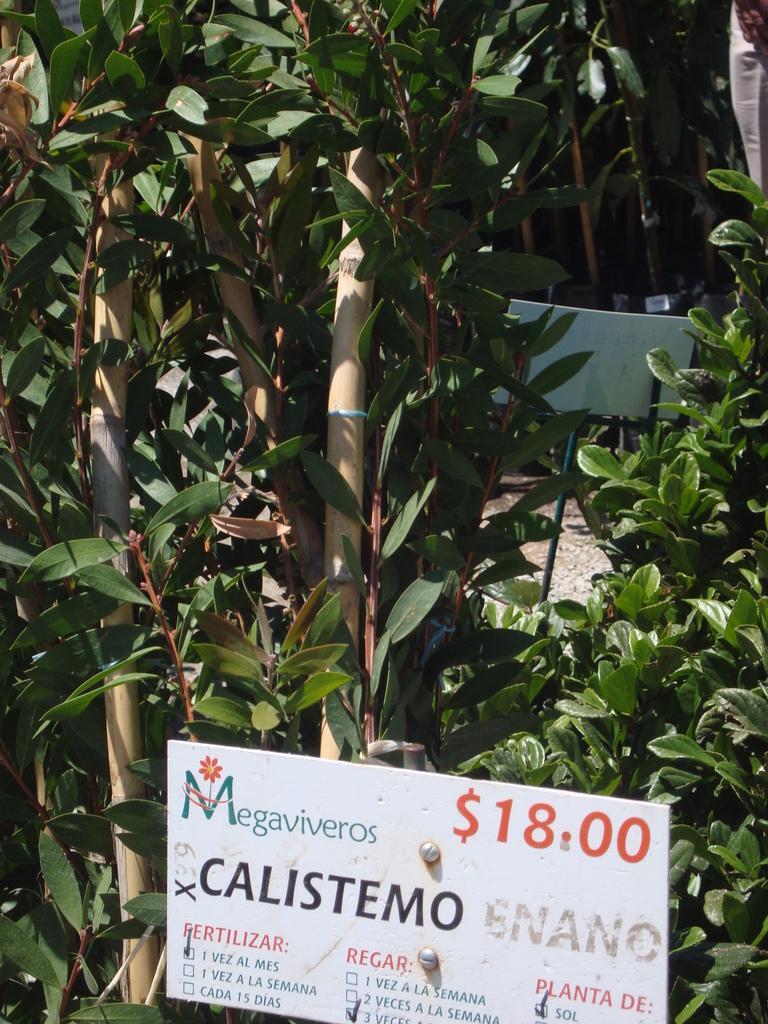Describe this image in one or two sentences. In this image, we can see some plants. There is board at the bottom of the image contains some text. 